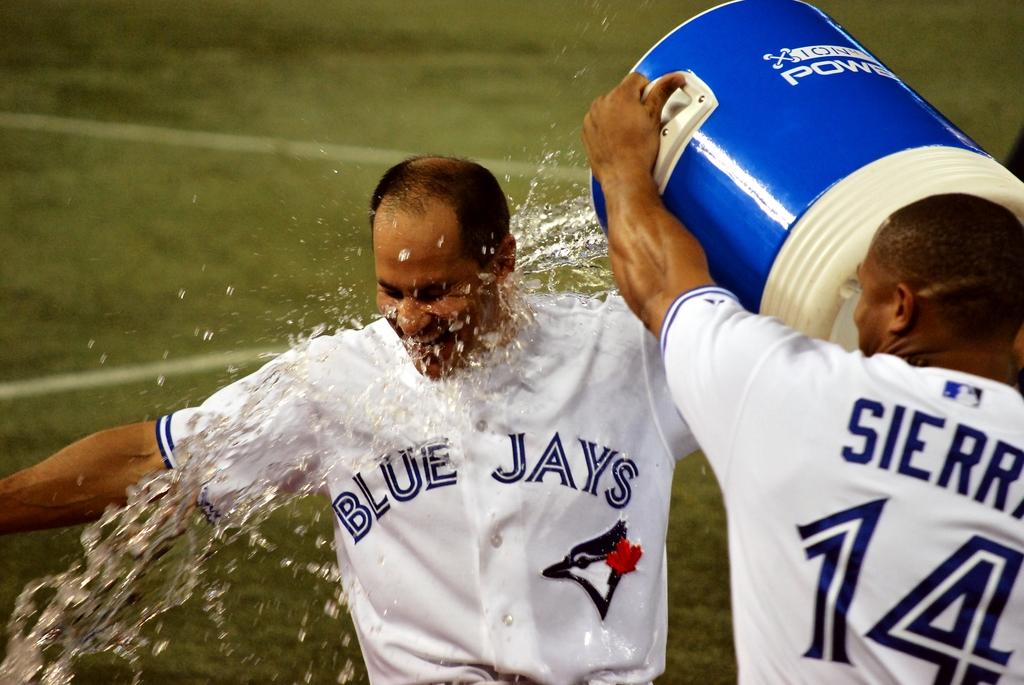What is the name of the team?
Provide a succinct answer. Blue jays. What is the number on the back of the players' jersey?
Your answer should be very brief. 14. 